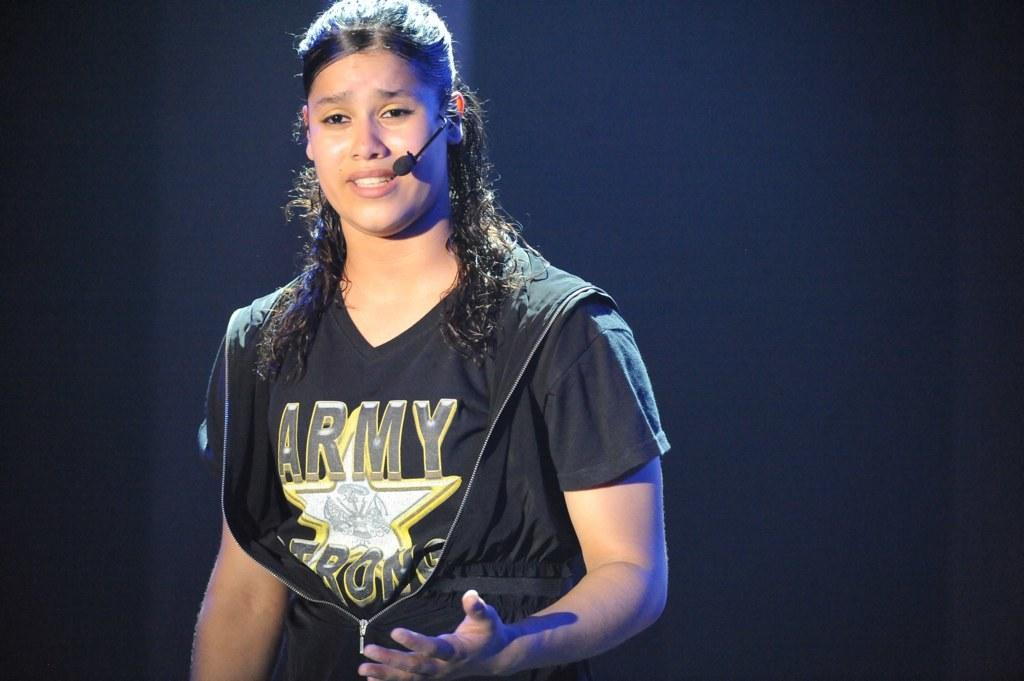<image>
Describe the image concisely. A woman with an emotional expression wears an Army Strong t-shirt. 